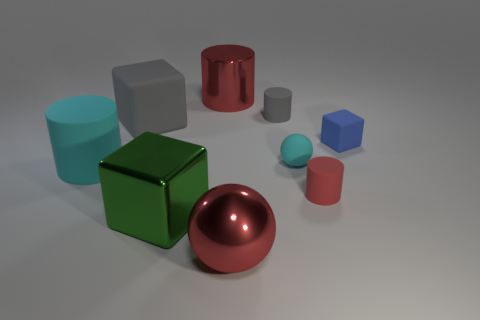Is the shape of the red rubber thing the same as the metallic object that is in front of the big green thing?
Give a very brief answer. No. There is a big thing that is the same color as the large metallic cylinder; what is its shape?
Your answer should be compact. Sphere. Is there a large red sphere that has the same material as the green cube?
Your answer should be compact. Yes. Are there any other things that have the same material as the big red cylinder?
Make the answer very short. Yes. What material is the thing that is right of the red cylinder on the right side of the small ball made of?
Provide a short and direct response. Rubber. What is the size of the block right of the ball that is in front of the matte cylinder that is on the right side of the tiny rubber sphere?
Your response must be concise. Small. How many other things are there of the same shape as the big green thing?
Provide a succinct answer. 2. There is a big matte object that is in front of the blue thing; is it the same color as the small matte cylinder behind the small blue rubber thing?
Keep it short and to the point. No. What is the color of the metal block that is the same size as the cyan cylinder?
Give a very brief answer. Green. Are there any tiny things of the same color as the metallic sphere?
Make the answer very short. Yes. 